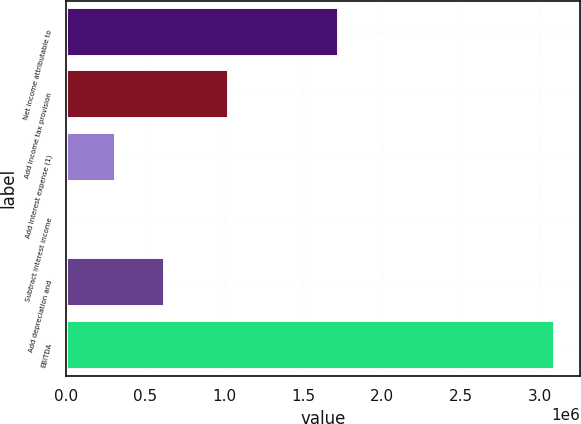Convert chart to OTSL. <chart><loc_0><loc_0><loc_500><loc_500><bar_chart><fcel>Net income attributable to<fcel>Add income tax provision<fcel>Add interest expense (1)<fcel>Subtract interest income<fcel>Add depreciation and<fcel>EBITDA<nl><fcel>1.72717e+06<fcel>1.02796e+06<fcel>314048<fcel>4786<fcel>623309<fcel>3.0974e+06<nl></chart> 